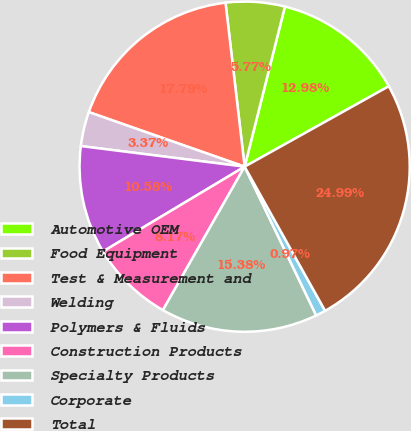<chart> <loc_0><loc_0><loc_500><loc_500><pie_chart><fcel>Automotive OEM<fcel>Food Equipment<fcel>Test & Measurement and<fcel>Welding<fcel>Polymers & Fluids<fcel>Construction Products<fcel>Specialty Products<fcel>Corporate<fcel>Total<nl><fcel>12.98%<fcel>5.77%<fcel>17.79%<fcel>3.37%<fcel>10.58%<fcel>8.17%<fcel>15.38%<fcel>0.97%<fcel>24.99%<nl></chart> 